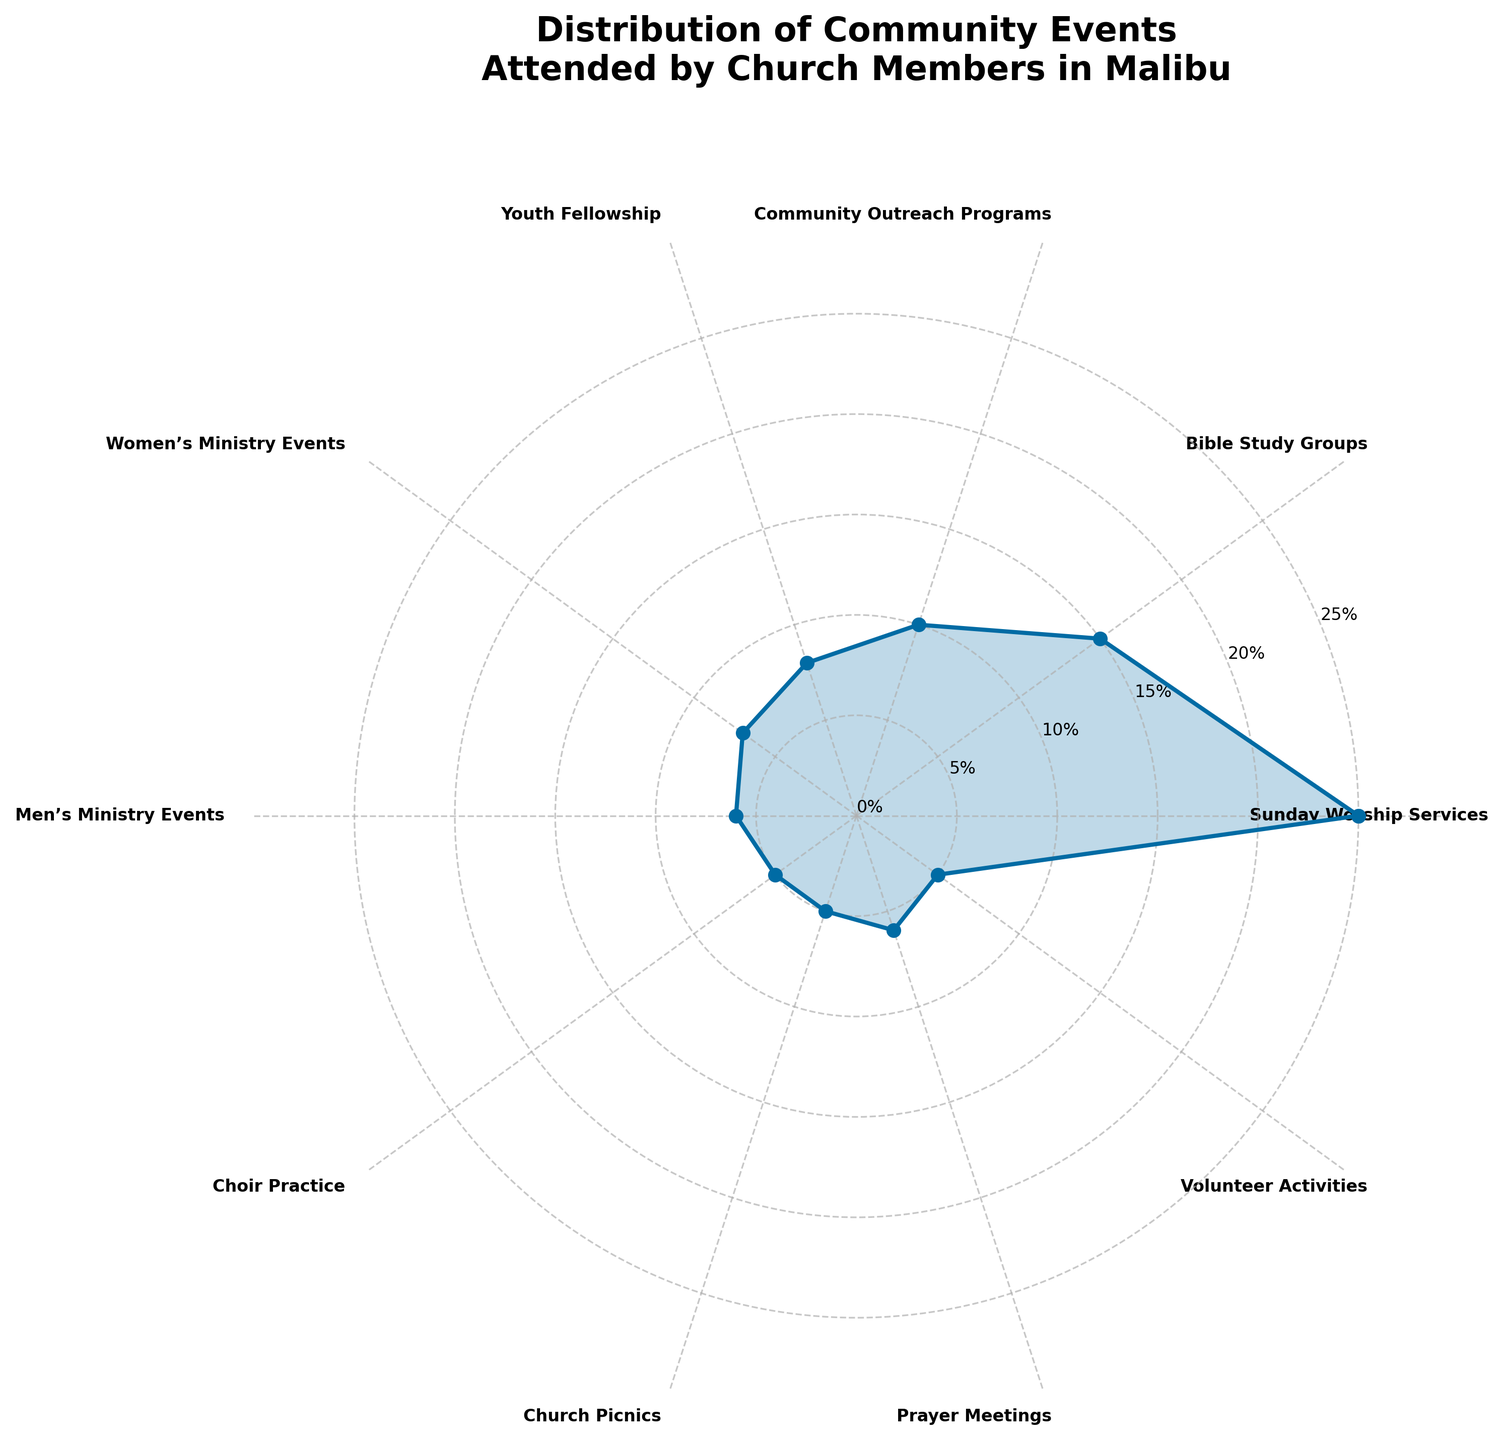Which community event has the highest attendance percentage? The rose chart shows the largest segment corresponding to "Sunday Worship Services" at 25%. Hence, it is the community event with the highest attendance percentage.
Answer: Sunday Worship Services Which event has a higher attendance percentage: Choir Practice or Men’s Ministry Events? The rose chart shows that Choir Practice has an attendance percentage of 5%, whereas Men’s Ministry Events have 6%. Therefore, Men’s Ministry Events have a higher attendance percentage compared to Choir Practice.
Answer: Men’s Ministry Events What is the combined attendance percentage of Youth Fellowship and Women's Ministry Events? Youth Fellowship accounts for 8% and Women's Ministry Events account for 7%. Adding these percentages together gives 8% + 7% = 15%.
Answer: 15% What is the title of the rose chart? The title of the rose chart is displayed at the top and reads "Distribution of Community Events Attended by Church Members in Malibu."
Answer: Distribution of Community Events Attended by Church Members in Malibu Which categories are closest in terms of attendance percentage? The rose chart shows that Choir Practice, Church Picnics, and Volunteer Activities each have an attendance percentage of 5%. Hence, these categories are closest in terms of attendance percentage.
Answer: Choir Practice, Church Picnics, Volunteer Activities How much higher is the percentage of people attending Sunday Worship Services compared to Community Outreach Programs? The chart indicates that Sunday Worship Services have a 25% attendance, while Community Outreach Programs have 10%. Subtracting the latter from the former gives 25% - 10% = 15%.
Answer: 15% What is the smallest segment on the rose chart? The smallest segment on the chart corresponds to both Choir Practice, Church Picnics, and Volunteer Activities, each with an attendance percentage of 5%.
Answer: Choir Practice, Church Picnics, Volunteer Activities Is the percentage of people attending Bible Study Groups greater or lesser than that of Youth Fellowship? The rose chart illustrates that Bible Study Groups have an attendance percentage of 15%, whereas Youth Fellowship has 8%. Thus, the attendance for Bible Study Groups is greater.
Answer: Greater 